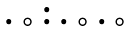<formula> <loc_0><loc_0><loc_500><loc_500>\begin{smallmatrix} & & \bullet \\ \bullet & \circ & \bullet & \bullet & \circ & \bullet & \circ & \\ \end{smallmatrix}</formula> 